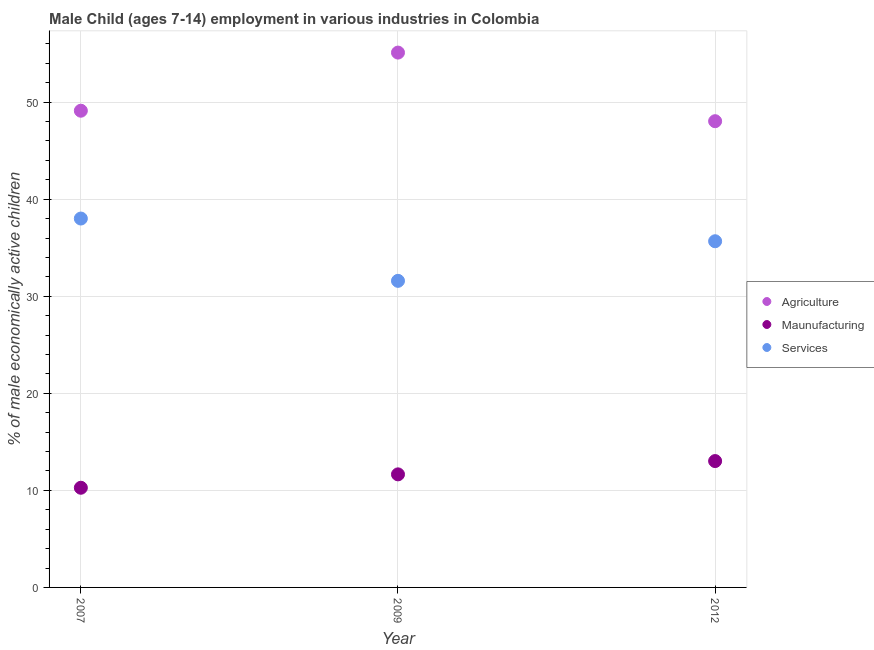How many different coloured dotlines are there?
Keep it short and to the point. 3. What is the percentage of economically active children in agriculture in 2007?
Ensure brevity in your answer.  49.12. Across all years, what is the maximum percentage of economically active children in services?
Your answer should be compact. 38.01. Across all years, what is the minimum percentage of economically active children in services?
Offer a very short reply. 31.59. What is the total percentage of economically active children in services in the graph?
Offer a terse response. 105.27. What is the difference between the percentage of economically active children in services in 2007 and that in 2012?
Offer a very short reply. 2.34. What is the difference between the percentage of economically active children in manufacturing in 2007 and the percentage of economically active children in services in 2012?
Give a very brief answer. -25.4. What is the average percentage of economically active children in agriculture per year?
Your answer should be very brief. 50.76. In the year 2009, what is the difference between the percentage of economically active children in services and percentage of economically active children in agriculture?
Your response must be concise. -23.52. In how many years, is the percentage of economically active children in manufacturing greater than 2 %?
Your answer should be very brief. 3. What is the ratio of the percentage of economically active children in services in 2007 to that in 2012?
Provide a succinct answer. 1.07. Is the percentage of economically active children in agriculture in 2009 less than that in 2012?
Make the answer very short. No. Is the difference between the percentage of economically active children in manufacturing in 2009 and 2012 greater than the difference between the percentage of economically active children in agriculture in 2009 and 2012?
Offer a terse response. No. What is the difference between the highest and the second highest percentage of economically active children in manufacturing?
Provide a short and direct response. 1.37. What is the difference between the highest and the lowest percentage of economically active children in services?
Offer a very short reply. 6.42. In how many years, is the percentage of economically active children in services greater than the average percentage of economically active children in services taken over all years?
Offer a very short reply. 2. Is it the case that in every year, the sum of the percentage of economically active children in agriculture and percentage of economically active children in manufacturing is greater than the percentage of economically active children in services?
Give a very brief answer. Yes. Is the percentage of economically active children in manufacturing strictly greater than the percentage of economically active children in services over the years?
Your answer should be very brief. No. What is the difference between two consecutive major ticks on the Y-axis?
Offer a very short reply. 10. Does the graph contain grids?
Make the answer very short. Yes. Where does the legend appear in the graph?
Make the answer very short. Center right. How many legend labels are there?
Offer a terse response. 3. How are the legend labels stacked?
Your answer should be compact. Vertical. What is the title of the graph?
Make the answer very short. Male Child (ages 7-14) employment in various industries in Colombia. Does "Male employers" appear as one of the legend labels in the graph?
Your answer should be compact. No. What is the label or title of the Y-axis?
Offer a very short reply. % of male economically active children. What is the % of male economically active children in Agriculture in 2007?
Offer a terse response. 49.12. What is the % of male economically active children in Maunufacturing in 2007?
Give a very brief answer. 10.27. What is the % of male economically active children in Services in 2007?
Your answer should be compact. 38.01. What is the % of male economically active children of Agriculture in 2009?
Your response must be concise. 55.11. What is the % of male economically active children of Maunufacturing in 2009?
Provide a short and direct response. 11.65. What is the % of male economically active children of Services in 2009?
Offer a very short reply. 31.59. What is the % of male economically active children of Agriculture in 2012?
Ensure brevity in your answer.  48.04. What is the % of male economically active children of Maunufacturing in 2012?
Your answer should be compact. 13.02. What is the % of male economically active children of Services in 2012?
Offer a terse response. 35.67. Across all years, what is the maximum % of male economically active children in Agriculture?
Ensure brevity in your answer.  55.11. Across all years, what is the maximum % of male economically active children of Maunufacturing?
Your answer should be very brief. 13.02. Across all years, what is the maximum % of male economically active children of Services?
Give a very brief answer. 38.01. Across all years, what is the minimum % of male economically active children in Agriculture?
Provide a succinct answer. 48.04. Across all years, what is the minimum % of male economically active children of Maunufacturing?
Keep it short and to the point. 10.27. Across all years, what is the minimum % of male economically active children in Services?
Keep it short and to the point. 31.59. What is the total % of male economically active children in Agriculture in the graph?
Give a very brief answer. 152.27. What is the total % of male economically active children of Maunufacturing in the graph?
Offer a very short reply. 34.94. What is the total % of male economically active children in Services in the graph?
Ensure brevity in your answer.  105.27. What is the difference between the % of male economically active children of Agriculture in 2007 and that in 2009?
Ensure brevity in your answer.  -5.99. What is the difference between the % of male economically active children in Maunufacturing in 2007 and that in 2009?
Make the answer very short. -1.38. What is the difference between the % of male economically active children in Services in 2007 and that in 2009?
Keep it short and to the point. 6.42. What is the difference between the % of male economically active children in Agriculture in 2007 and that in 2012?
Provide a short and direct response. 1.08. What is the difference between the % of male economically active children in Maunufacturing in 2007 and that in 2012?
Your response must be concise. -2.75. What is the difference between the % of male economically active children of Services in 2007 and that in 2012?
Make the answer very short. 2.34. What is the difference between the % of male economically active children in Agriculture in 2009 and that in 2012?
Offer a terse response. 7.07. What is the difference between the % of male economically active children of Maunufacturing in 2009 and that in 2012?
Keep it short and to the point. -1.37. What is the difference between the % of male economically active children in Services in 2009 and that in 2012?
Make the answer very short. -4.08. What is the difference between the % of male economically active children of Agriculture in 2007 and the % of male economically active children of Maunufacturing in 2009?
Provide a succinct answer. 37.47. What is the difference between the % of male economically active children in Agriculture in 2007 and the % of male economically active children in Services in 2009?
Your response must be concise. 17.53. What is the difference between the % of male economically active children of Maunufacturing in 2007 and the % of male economically active children of Services in 2009?
Your response must be concise. -21.32. What is the difference between the % of male economically active children in Agriculture in 2007 and the % of male economically active children in Maunufacturing in 2012?
Provide a short and direct response. 36.1. What is the difference between the % of male economically active children of Agriculture in 2007 and the % of male economically active children of Services in 2012?
Your answer should be compact. 13.45. What is the difference between the % of male economically active children of Maunufacturing in 2007 and the % of male economically active children of Services in 2012?
Give a very brief answer. -25.4. What is the difference between the % of male economically active children in Agriculture in 2009 and the % of male economically active children in Maunufacturing in 2012?
Your response must be concise. 42.09. What is the difference between the % of male economically active children in Agriculture in 2009 and the % of male economically active children in Services in 2012?
Give a very brief answer. 19.44. What is the difference between the % of male economically active children of Maunufacturing in 2009 and the % of male economically active children of Services in 2012?
Make the answer very short. -24.02. What is the average % of male economically active children of Agriculture per year?
Offer a very short reply. 50.76. What is the average % of male economically active children of Maunufacturing per year?
Your answer should be very brief. 11.65. What is the average % of male economically active children of Services per year?
Keep it short and to the point. 35.09. In the year 2007, what is the difference between the % of male economically active children in Agriculture and % of male economically active children in Maunufacturing?
Give a very brief answer. 38.85. In the year 2007, what is the difference between the % of male economically active children in Agriculture and % of male economically active children in Services?
Your response must be concise. 11.11. In the year 2007, what is the difference between the % of male economically active children in Maunufacturing and % of male economically active children in Services?
Provide a short and direct response. -27.74. In the year 2009, what is the difference between the % of male economically active children in Agriculture and % of male economically active children in Maunufacturing?
Offer a terse response. 43.46. In the year 2009, what is the difference between the % of male economically active children of Agriculture and % of male economically active children of Services?
Ensure brevity in your answer.  23.52. In the year 2009, what is the difference between the % of male economically active children in Maunufacturing and % of male economically active children in Services?
Ensure brevity in your answer.  -19.94. In the year 2012, what is the difference between the % of male economically active children in Agriculture and % of male economically active children in Maunufacturing?
Offer a terse response. 35.02. In the year 2012, what is the difference between the % of male economically active children of Agriculture and % of male economically active children of Services?
Your answer should be compact. 12.37. In the year 2012, what is the difference between the % of male economically active children of Maunufacturing and % of male economically active children of Services?
Your response must be concise. -22.65. What is the ratio of the % of male economically active children of Agriculture in 2007 to that in 2009?
Offer a very short reply. 0.89. What is the ratio of the % of male economically active children in Maunufacturing in 2007 to that in 2009?
Your response must be concise. 0.88. What is the ratio of the % of male economically active children of Services in 2007 to that in 2009?
Your response must be concise. 1.2. What is the ratio of the % of male economically active children in Agriculture in 2007 to that in 2012?
Your answer should be very brief. 1.02. What is the ratio of the % of male economically active children in Maunufacturing in 2007 to that in 2012?
Your answer should be very brief. 0.79. What is the ratio of the % of male economically active children of Services in 2007 to that in 2012?
Provide a succinct answer. 1.07. What is the ratio of the % of male economically active children of Agriculture in 2009 to that in 2012?
Give a very brief answer. 1.15. What is the ratio of the % of male economically active children in Maunufacturing in 2009 to that in 2012?
Your answer should be very brief. 0.89. What is the ratio of the % of male economically active children in Services in 2009 to that in 2012?
Make the answer very short. 0.89. What is the difference between the highest and the second highest % of male economically active children in Agriculture?
Keep it short and to the point. 5.99. What is the difference between the highest and the second highest % of male economically active children in Maunufacturing?
Keep it short and to the point. 1.37. What is the difference between the highest and the second highest % of male economically active children in Services?
Ensure brevity in your answer.  2.34. What is the difference between the highest and the lowest % of male economically active children in Agriculture?
Provide a short and direct response. 7.07. What is the difference between the highest and the lowest % of male economically active children in Maunufacturing?
Your answer should be compact. 2.75. What is the difference between the highest and the lowest % of male economically active children in Services?
Offer a very short reply. 6.42. 